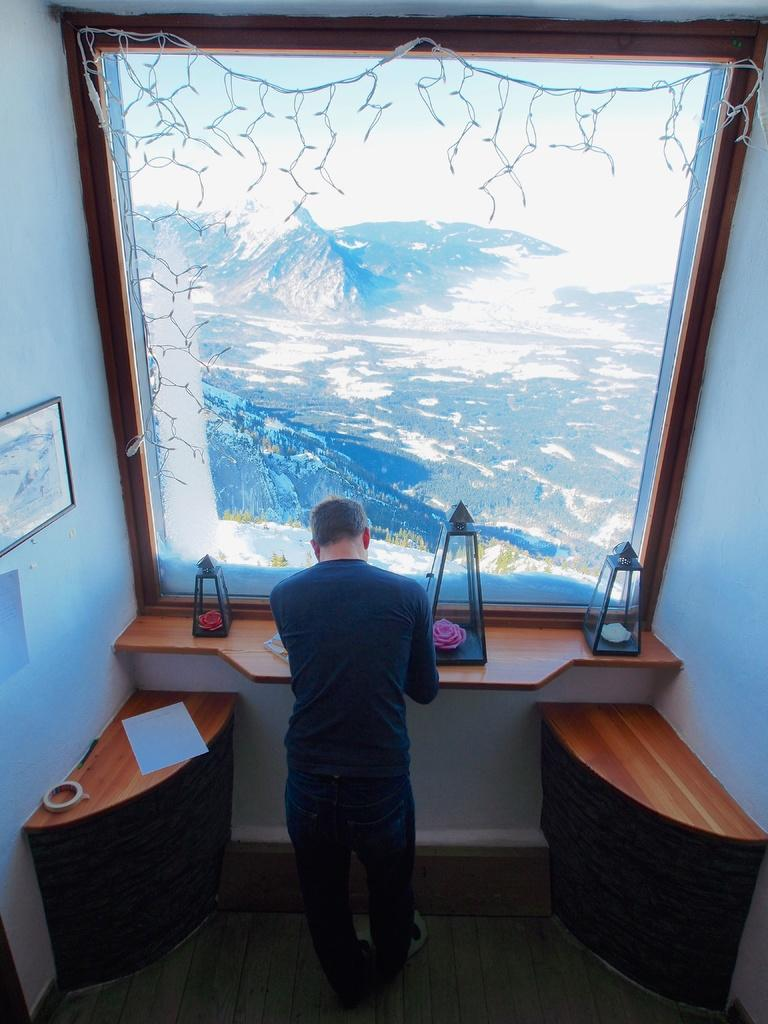What is the main subject of the image? There is a man standing in the image. What can be seen in the background of the image? There is a paper and a wall in the background of the image. How does the man control the drain in the image? There is no drain present in the image, so the man cannot control it. 